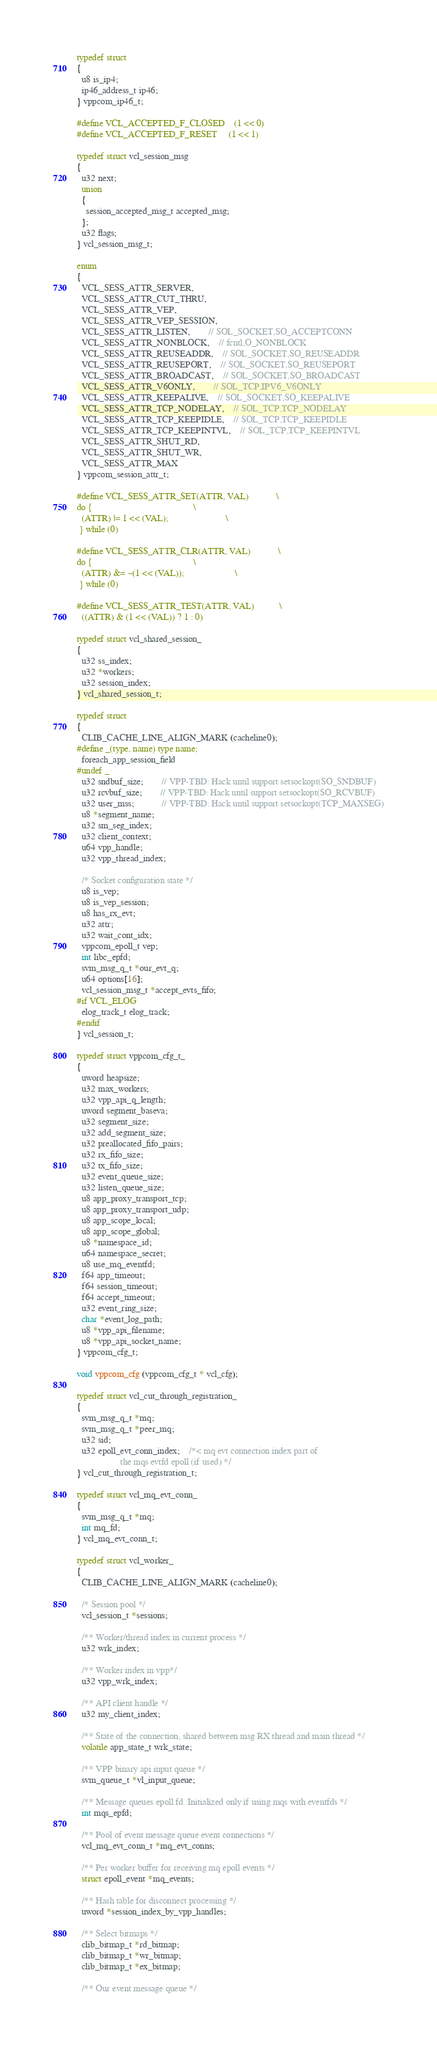Convert code to text. <code><loc_0><loc_0><loc_500><loc_500><_C_>typedef struct
{
  u8 is_ip4;
  ip46_address_t ip46;
} vppcom_ip46_t;

#define VCL_ACCEPTED_F_CLOSED 	(1 << 0)
#define VCL_ACCEPTED_F_RESET 	(1 << 1)

typedef struct vcl_session_msg
{
  u32 next;
  union
  {
    session_accepted_msg_t accepted_msg;
  };
  u32 flags;
} vcl_session_msg_t;

enum
{
  VCL_SESS_ATTR_SERVER,
  VCL_SESS_ATTR_CUT_THRU,
  VCL_SESS_ATTR_VEP,
  VCL_SESS_ATTR_VEP_SESSION,
  VCL_SESS_ATTR_LISTEN,		// SOL_SOCKET,SO_ACCEPTCONN
  VCL_SESS_ATTR_NONBLOCK,	// fcntl,O_NONBLOCK
  VCL_SESS_ATTR_REUSEADDR,	// SOL_SOCKET,SO_REUSEADDR
  VCL_SESS_ATTR_REUSEPORT,	// SOL_SOCKET,SO_REUSEPORT
  VCL_SESS_ATTR_BROADCAST,	// SOL_SOCKET,SO_BROADCAST
  VCL_SESS_ATTR_V6ONLY,		// SOL_TCP,IPV6_V6ONLY
  VCL_SESS_ATTR_KEEPALIVE,	// SOL_SOCKET,SO_KEEPALIVE
  VCL_SESS_ATTR_TCP_NODELAY,	// SOL_TCP,TCP_NODELAY
  VCL_SESS_ATTR_TCP_KEEPIDLE,	// SOL_TCP,TCP_KEEPIDLE
  VCL_SESS_ATTR_TCP_KEEPINTVL,	// SOL_TCP,TCP_KEEPINTVL
  VCL_SESS_ATTR_SHUT_RD,
  VCL_SESS_ATTR_SHUT_WR,
  VCL_SESS_ATTR_MAX
} vppcom_session_attr_t;

#define VCL_SESS_ATTR_SET(ATTR, VAL)            \
do {                                            \
  (ATTR) |= 1 << (VAL);                         \
 } while (0)

#define VCL_SESS_ATTR_CLR(ATTR, VAL)            \
do {                                            \
  (ATTR) &= ~(1 << (VAL));                      \
 } while (0)

#define VCL_SESS_ATTR_TEST(ATTR, VAL)           \
  ((ATTR) & (1 << (VAL)) ? 1 : 0)

typedef struct vcl_shared_session_
{
  u32 ss_index;
  u32 *workers;
  u32 session_index;
} vcl_shared_session_t;

typedef struct
{
  CLIB_CACHE_LINE_ALIGN_MARK (cacheline0);
#define _(type, name) type name;
  foreach_app_session_field
#undef _
  u32 sndbuf_size;		// VPP-TBD: Hack until support setsockopt(SO_SNDBUF)
  u32 rcvbuf_size;		// VPP-TBD: Hack until support setsockopt(SO_RCVBUF)
  u32 user_mss;			// VPP-TBD: Hack until support setsockopt(TCP_MAXSEG)
  u8 *segment_name;
  u32 sm_seg_index;
  u32 client_context;
  u64 vpp_handle;
  u32 vpp_thread_index;

  /* Socket configuration state */
  u8 is_vep;
  u8 is_vep_session;
  u8 has_rx_evt;
  u32 attr;
  u32 wait_cont_idx;
  vppcom_epoll_t vep;
  int libc_epfd;
  svm_msg_q_t *our_evt_q;
  u64 options[16];
  vcl_session_msg_t *accept_evts_fifo;
#if VCL_ELOG
  elog_track_t elog_track;
#endif
} vcl_session_t;

typedef struct vppcom_cfg_t_
{
  uword heapsize;
  u32 max_workers;
  u32 vpp_api_q_length;
  uword segment_baseva;
  u32 segment_size;
  u32 add_segment_size;
  u32 preallocated_fifo_pairs;
  u32 rx_fifo_size;
  u32 tx_fifo_size;
  u32 event_queue_size;
  u32 listen_queue_size;
  u8 app_proxy_transport_tcp;
  u8 app_proxy_transport_udp;
  u8 app_scope_local;
  u8 app_scope_global;
  u8 *namespace_id;
  u64 namespace_secret;
  u8 use_mq_eventfd;
  f64 app_timeout;
  f64 session_timeout;
  f64 accept_timeout;
  u32 event_ring_size;
  char *event_log_path;
  u8 *vpp_api_filename;
  u8 *vpp_api_socket_name;
} vppcom_cfg_t;

void vppcom_cfg (vppcom_cfg_t * vcl_cfg);

typedef struct vcl_cut_through_registration_
{
  svm_msg_q_t *mq;
  svm_msg_q_t *peer_mq;
  u32 sid;
  u32 epoll_evt_conn_index;	/*< mq evt connection index part of
				   the mqs evtfd epoll (if used) */
} vcl_cut_through_registration_t;

typedef struct vcl_mq_evt_conn_
{
  svm_msg_q_t *mq;
  int mq_fd;
} vcl_mq_evt_conn_t;

typedef struct vcl_worker_
{
  CLIB_CACHE_LINE_ALIGN_MARK (cacheline0);

  /* Session pool */
  vcl_session_t *sessions;

  /** Worker/thread index in current process */
  u32 wrk_index;

  /** Worker index in vpp*/
  u32 vpp_wrk_index;

  /** API client handle */
  u32 my_client_index;

  /** State of the connection, shared between msg RX thread and main thread */
  volatile app_state_t wrk_state;

  /** VPP binary api input queue */
  svm_queue_t *vl_input_queue;

  /** Message queues epoll fd. Initialized only if using mqs with eventfds */
  int mqs_epfd;

  /** Pool of event message queue event connections */
  vcl_mq_evt_conn_t *mq_evt_conns;

  /** Per worker buffer for receiving mq epoll events */
  struct epoll_event *mq_events;

  /** Hash table for disconnect processing */
  uword *session_index_by_vpp_handles;

  /** Select bitmaps */
  clib_bitmap_t *rd_bitmap;
  clib_bitmap_t *wr_bitmap;
  clib_bitmap_t *ex_bitmap;

  /** Our event message queue */</code> 